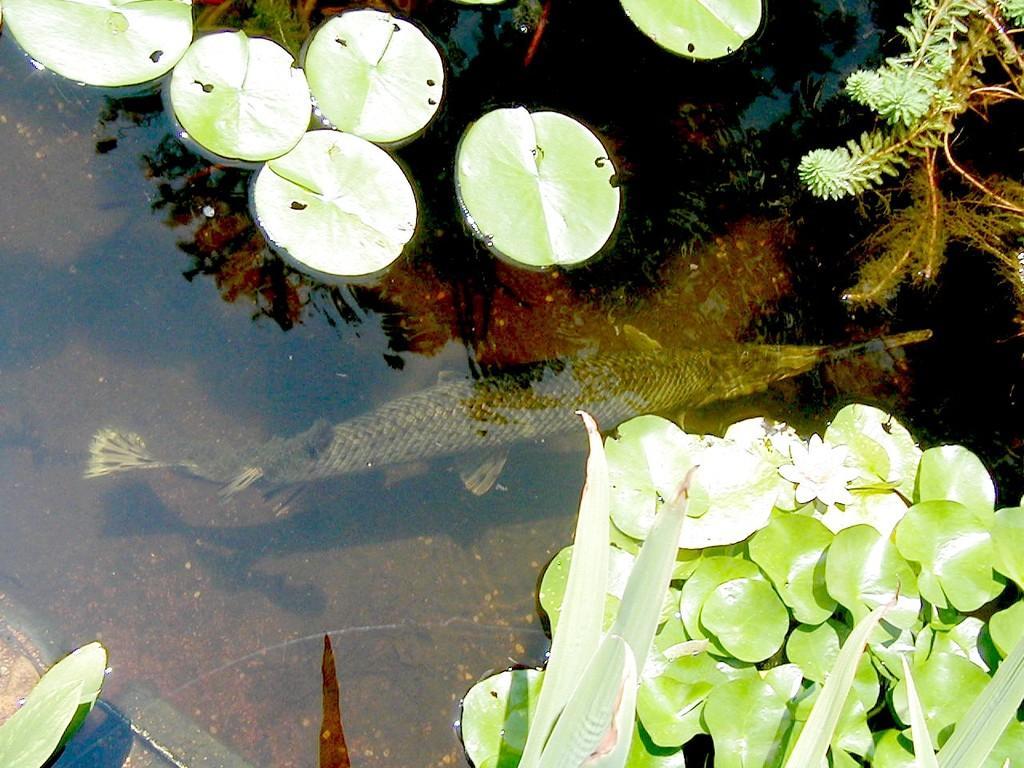Please provide a concise description of this image. In this picture we can see two fish in the water. On the bottom we can see leaves. On the top right there are grass. Here we can see tree and sky in the water reflection. 